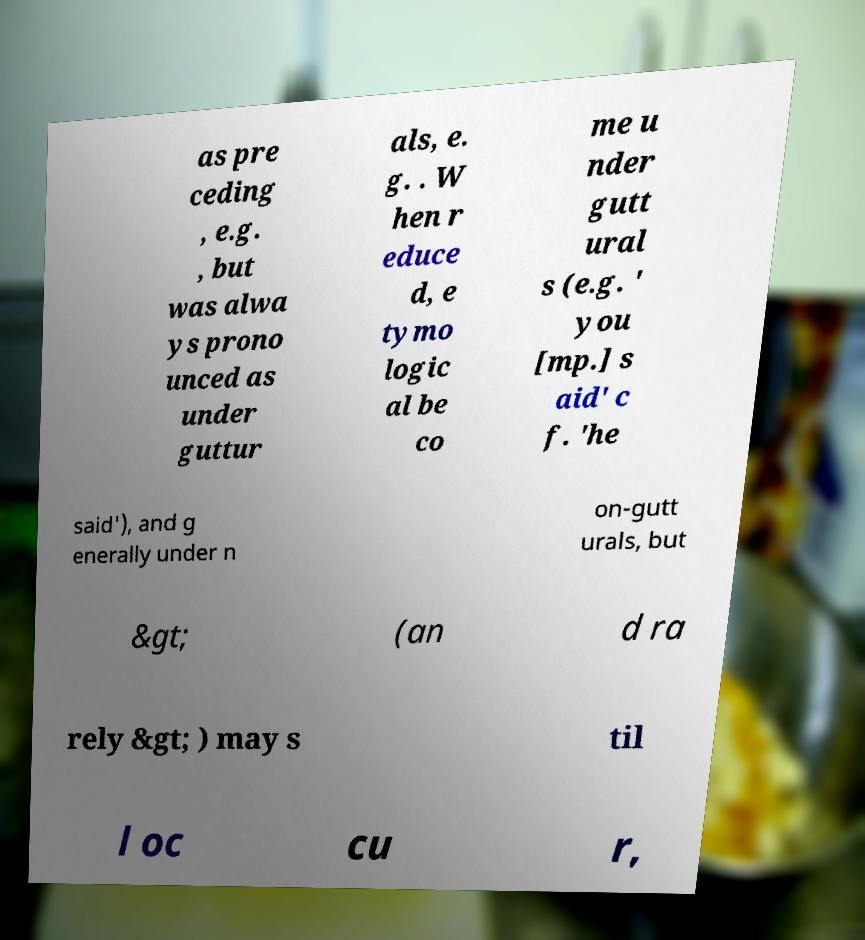I need the written content from this picture converted into text. Can you do that? as pre ceding , e.g. , but was alwa ys prono unced as under guttur als, e. g. . W hen r educe d, e tymo logic al be co me u nder gutt ural s (e.g. ' you [mp.] s aid' c f. 'he said'), and g enerally under n on-gutt urals, but &gt; (an d ra rely &gt; ) may s til l oc cu r, 